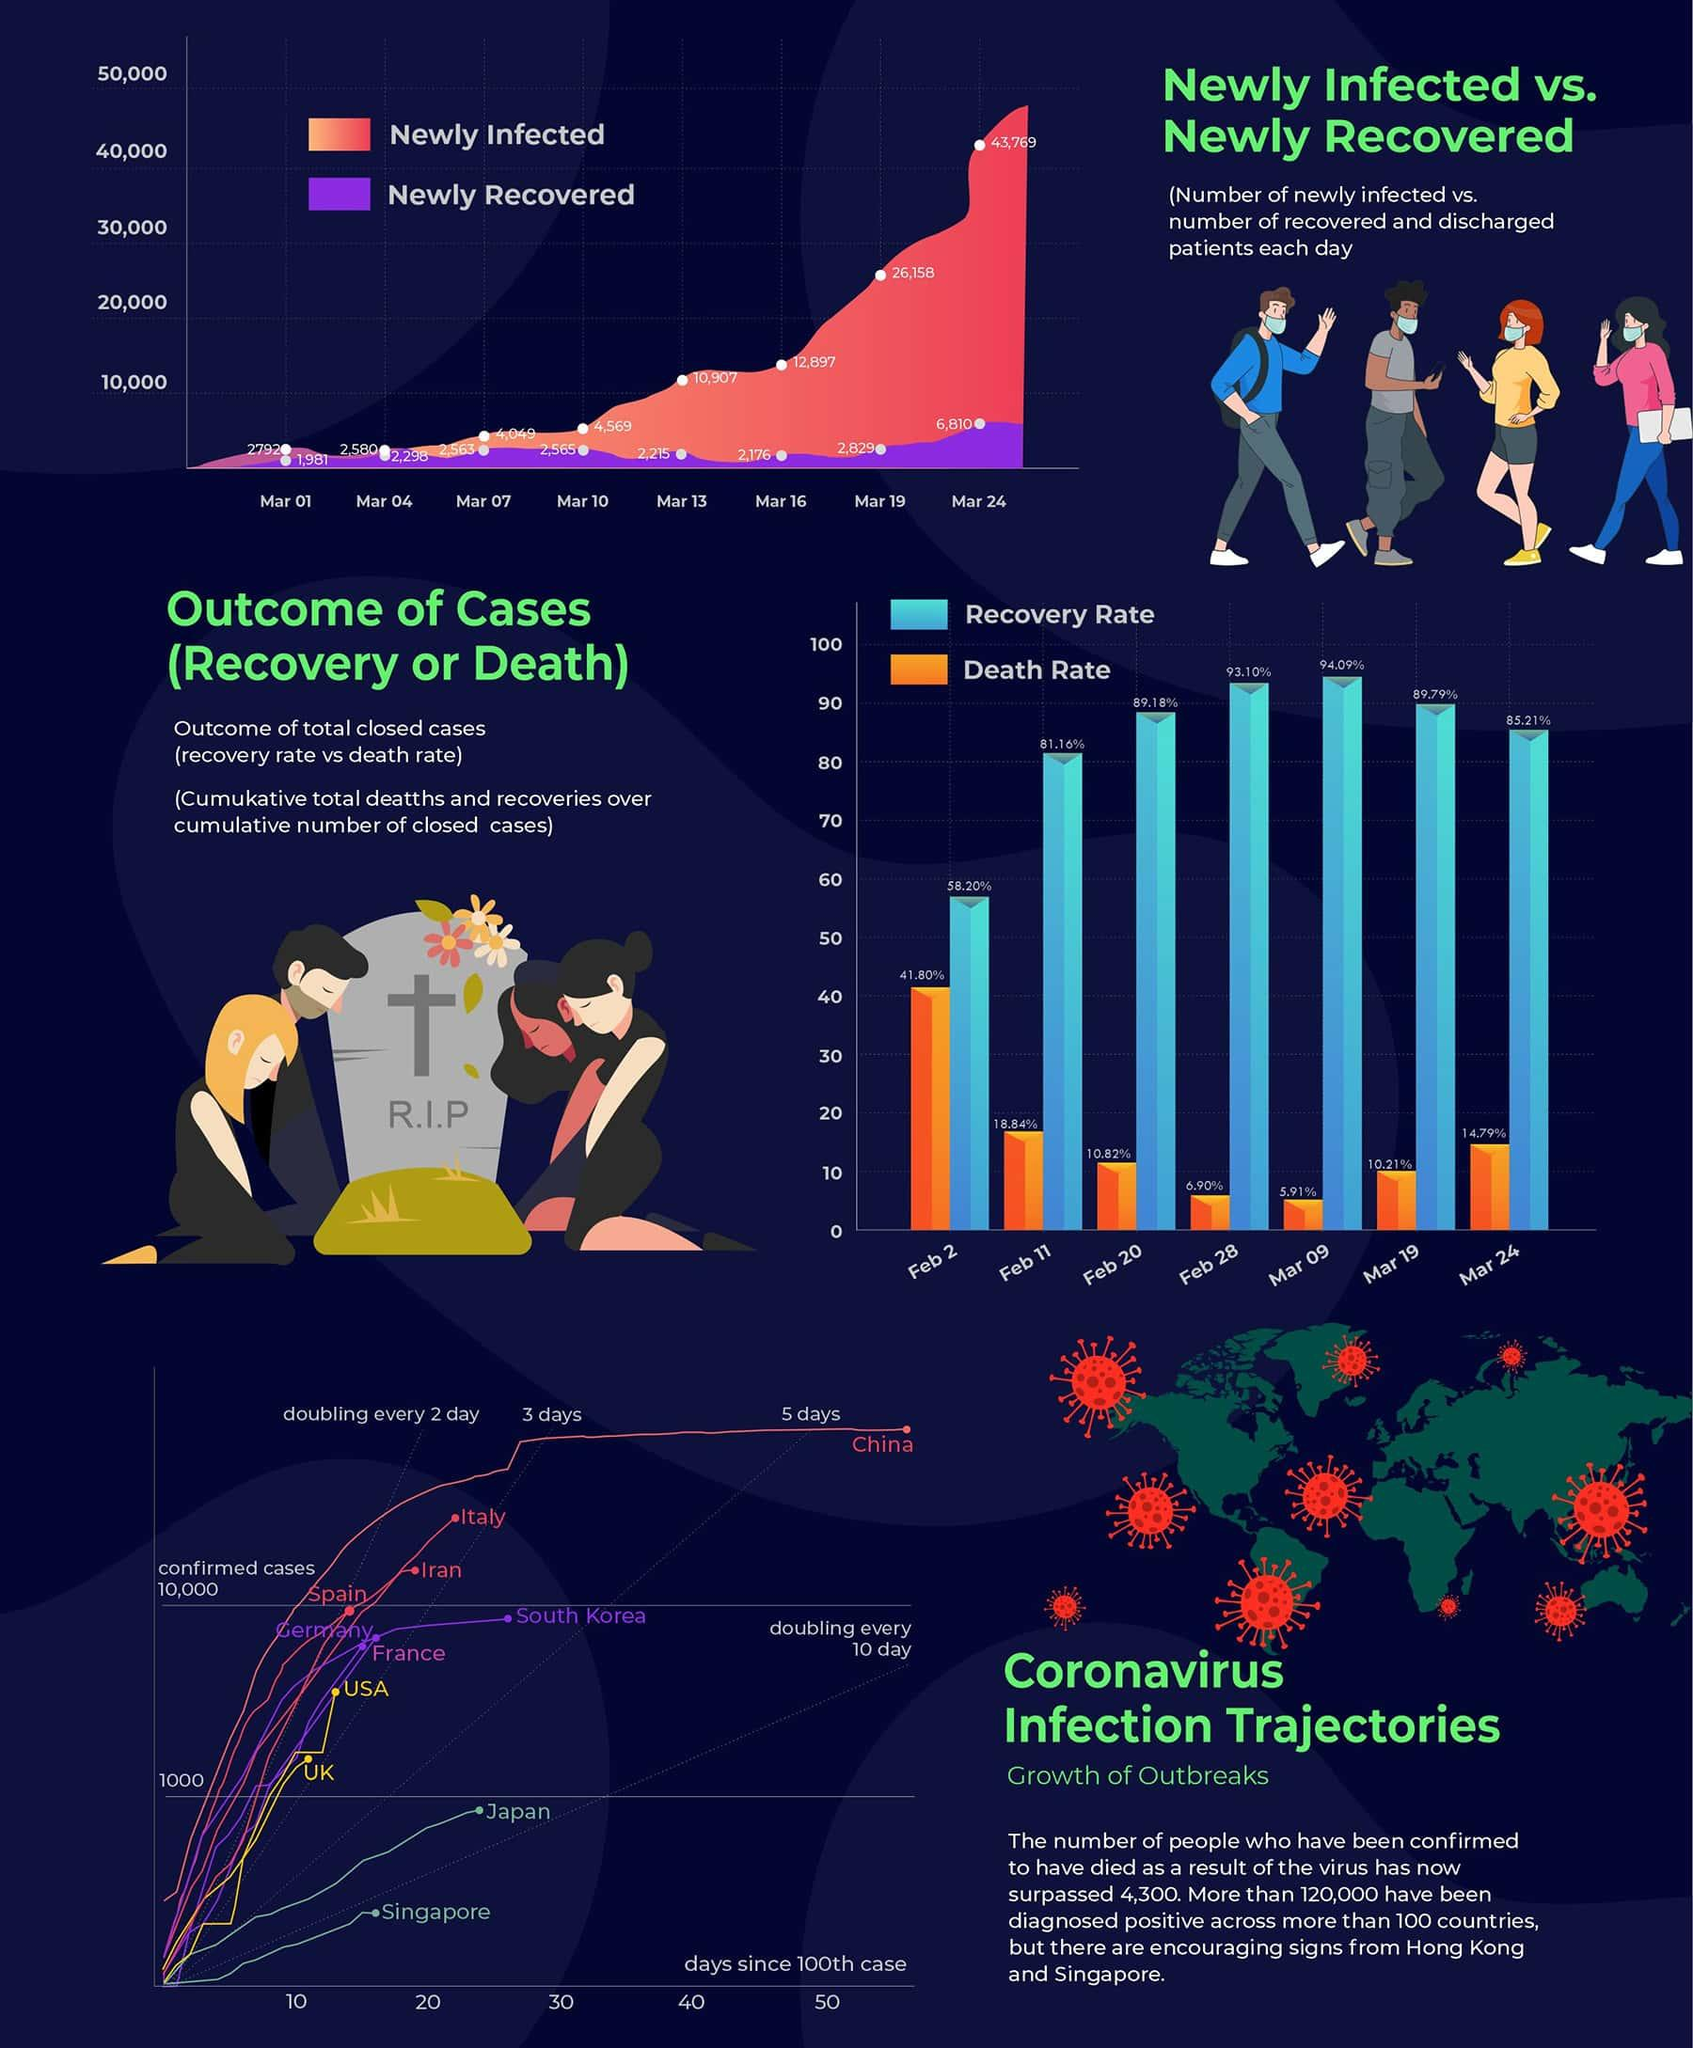Outline some significant characteristics in this image. On March 19th, there were 26,158 new COVID-19 cases reported globally. On March 24, the recovery rate of COVID-19 cases was reported to be 85.21%. On February 11, it was reported that the recovery rate of COVID-19 cases was 81.16%. On March 19, the death rate due to Covid-19 was 10.21%. On March 13, globally, 2,215 newly recovered COVID-19 cases were reported. 